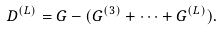<formula> <loc_0><loc_0><loc_500><loc_500>D ^ { ( L ) } = G - ( G ^ { ( 3 ) } + \cdots + G ^ { ( L ) } ) .</formula> 